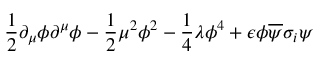<formula> <loc_0><loc_0><loc_500><loc_500>\frac { 1 } { 2 } \partial _ { \mu } \phi \partial ^ { \mu } \phi - \frac { 1 } { 2 } \mu ^ { 2 } \phi ^ { 2 } - \frac { 1 } { 4 } \lambda \phi ^ { 4 } + \epsilon \phi \overline { \psi } \sigma _ { i } \psi</formula> 